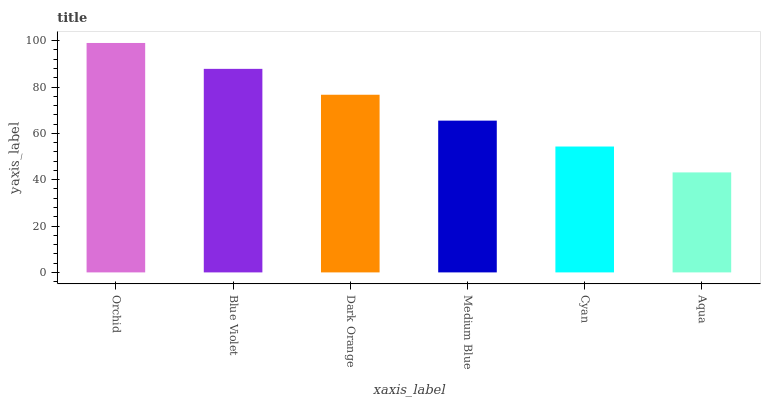Is Aqua the minimum?
Answer yes or no. Yes. Is Orchid the maximum?
Answer yes or no. Yes. Is Blue Violet the minimum?
Answer yes or no. No. Is Blue Violet the maximum?
Answer yes or no. No. Is Orchid greater than Blue Violet?
Answer yes or no. Yes. Is Blue Violet less than Orchid?
Answer yes or no. Yes. Is Blue Violet greater than Orchid?
Answer yes or no. No. Is Orchid less than Blue Violet?
Answer yes or no. No. Is Dark Orange the high median?
Answer yes or no. Yes. Is Medium Blue the low median?
Answer yes or no. Yes. Is Cyan the high median?
Answer yes or no. No. Is Aqua the low median?
Answer yes or no. No. 